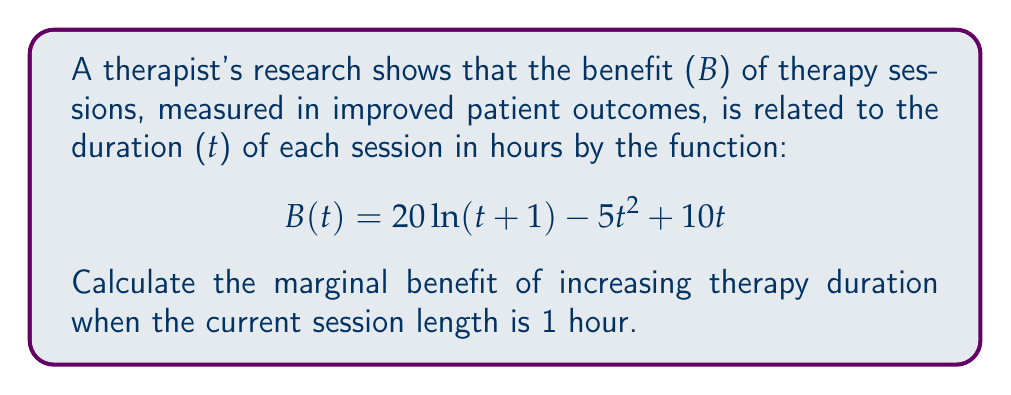Provide a solution to this math problem. To find the marginal benefit, we need to calculate the derivative of the benefit function B(t) with respect to t and then evaluate it at t = 1.

1) First, let's find the derivative of B(t):
   $$\frac{d}{dt}[20\ln(t+1)] = \frac{20}{t+1}$$
   $$\frac{d}{dt}[-5t^2] = -10t$$
   $$\frac{d}{dt}[10t] = 10$$

2) Combining these terms, we get the marginal benefit function:
   $$B'(t) = \frac{20}{t+1} - 10t + 10$$

3) Now, we evaluate this at t = 1:
   $$B'(1) = \frac{20}{1+1} - 10(1) + 10$$
   $$= 10 - 10 + 10 = 10$$

The marginal benefit represents the rate of change in benefit for a small increase in therapy duration. In this case, it's positive, indicating that increasing the therapy duration from 1 hour would still provide additional benefit.
Answer: $10$ 